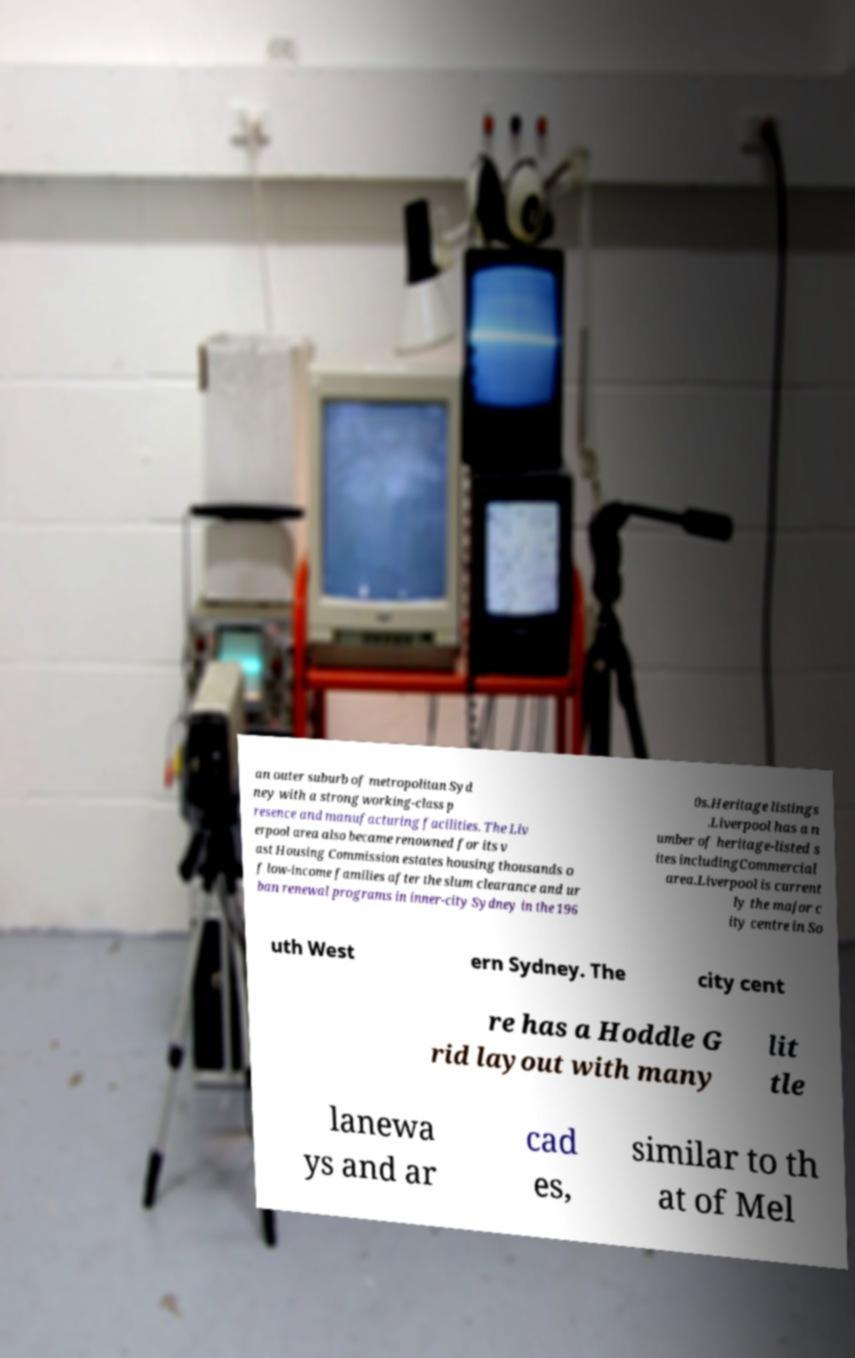Could you extract and type out the text from this image? an outer suburb of metropolitan Syd ney with a strong working-class p resence and manufacturing facilities. The Liv erpool area also became renowned for its v ast Housing Commission estates housing thousands o f low-income families after the slum clearance and ur ban renewal programs in inner-city Sydney in the 196 0s.Heritage listings .Liverpool has a n umber of heritage-listed s ites includingCommercial area.Liverpool is current ly the major c ity centre in So uth West ern Sydney. The city cent re has a Hoddle G rid layout with many lit tle lanewa ys and ar cad es, similar to th at of Mel 